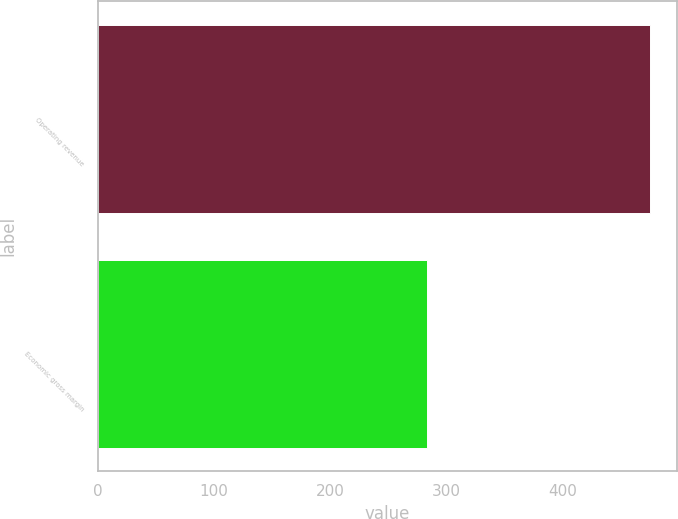Convert chart. <chart><loc_0><loc_0><loc_500><loc_500><bar_chart><fcel>Operating revenue<fcel>Economic gross margin<nl><fcel>475<fcel>283<nl></chart> 